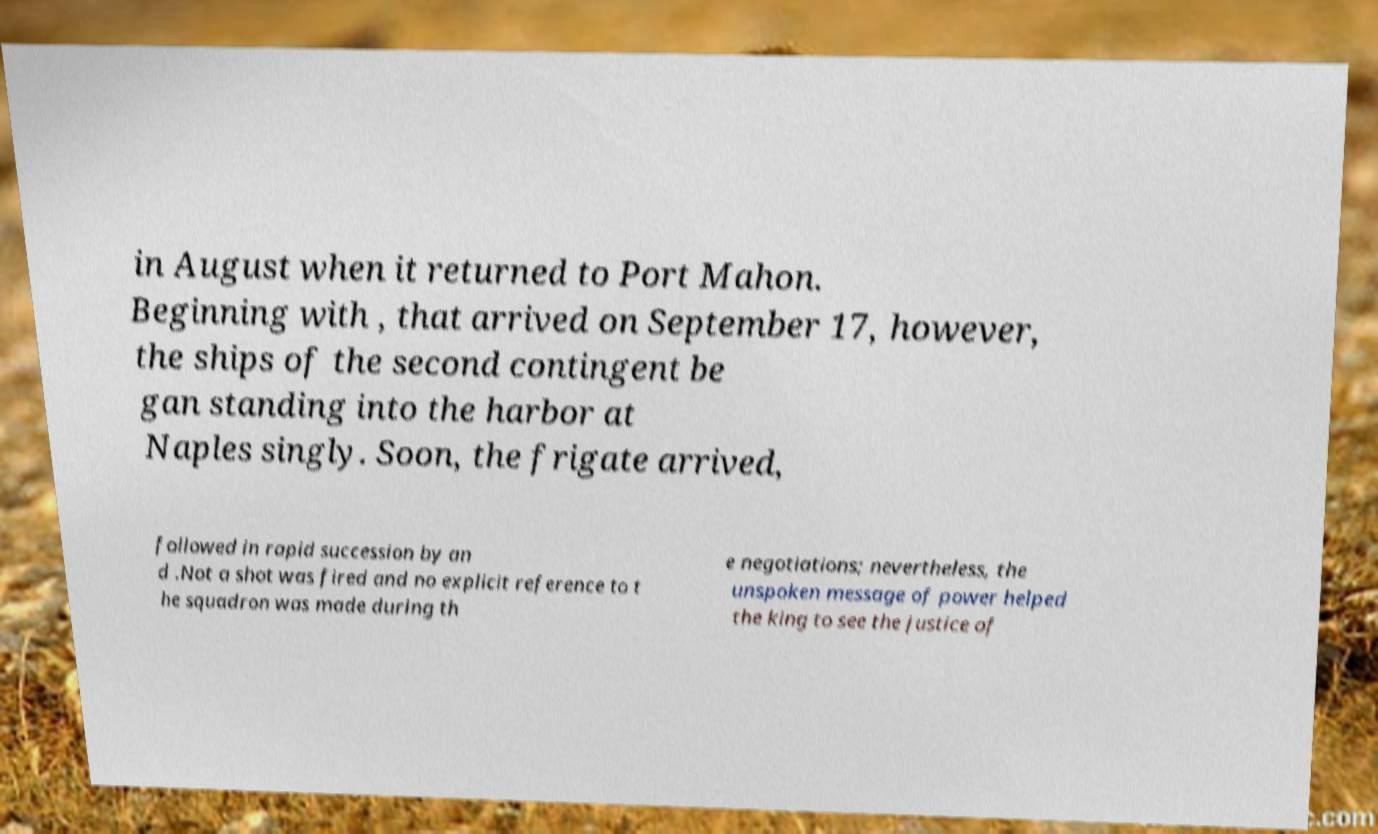Can you read and provide the text displayed in the image?This photo seems to have some interesting text. Can you extract and type it out for me? in August when it returned to Port Mahon. Beginning with , that arrived on September 17, however, the ships of the second contingent be gan standing into the harbor at Naples singly. Soon, the frigate arrived, followed in rapid succession by an d .Not a shot was fired and no explicit reference to t he squadron was made during th e negotiations; nevertheless, the unspoken message of power helped the king to see the justice of 